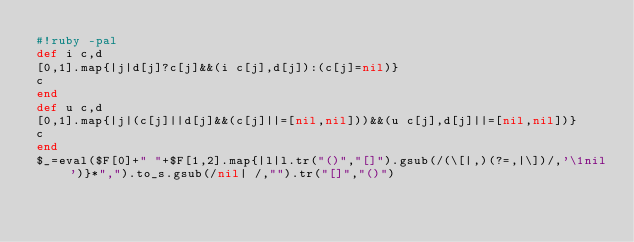Convert code to text. <code><loc_0><loc_0><loc_500><loc_500><_Ruby_>#!ruby -pal
def i c,d
[0,1].map{|j|d[j]?c[j]&&(i c[j],d[j]):(c[j]=nil)}
c
end
def u c,d
[0,1].map{|j|(c[j]||d[j]&&(c[j]||=[nil,nil]))&&(u c[j],d[j]||=[nil,nil])}
c
end
$_=eval($F[0]+" "+$F[1,2].map{|l|l.tr("()","[]").gsub(/(\[|,)(?=,|\])/,'\1nil')}*",").to_s.gsub(/nil| /,"").tr("[]","()")</code> 